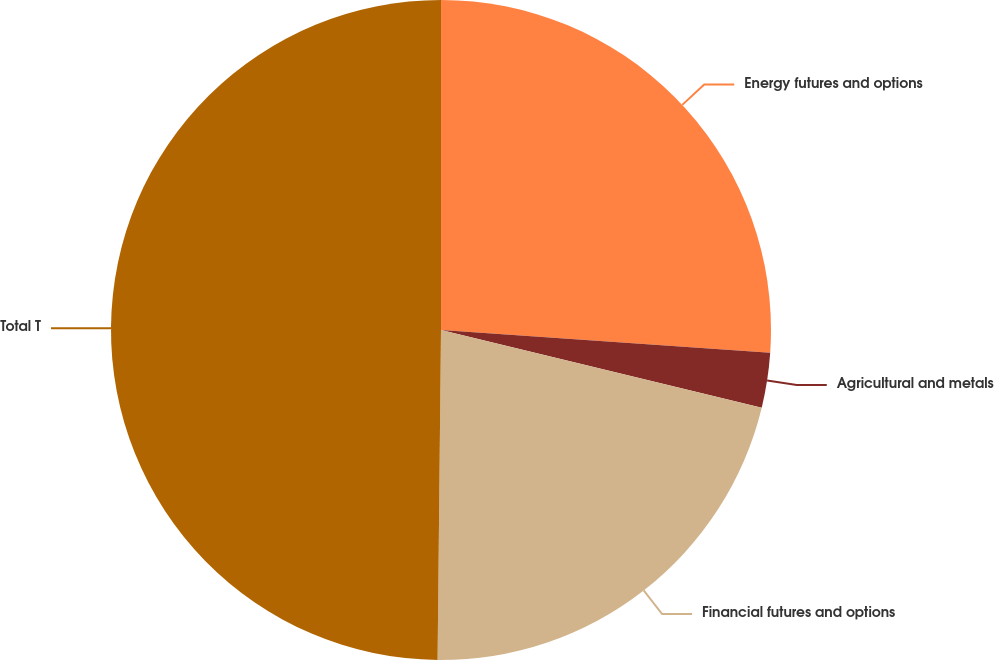Convert chart to OTSL. <chart><loc_0><loc_0><loc_500><loc_500><pie_chart><fcel>Energy futures and options<fcel>Agricultural and metals<fcel>Financial futures and options<fcel>Total T<nl><fcel>26.1%<fcel>2.68%<fcel>21.38%<fcel>49.83%<nl></chart> 